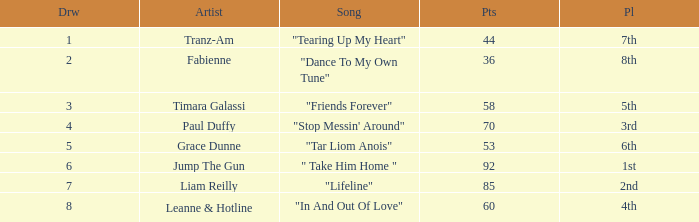What's the song of artist liam reilly? "Lifeline". 